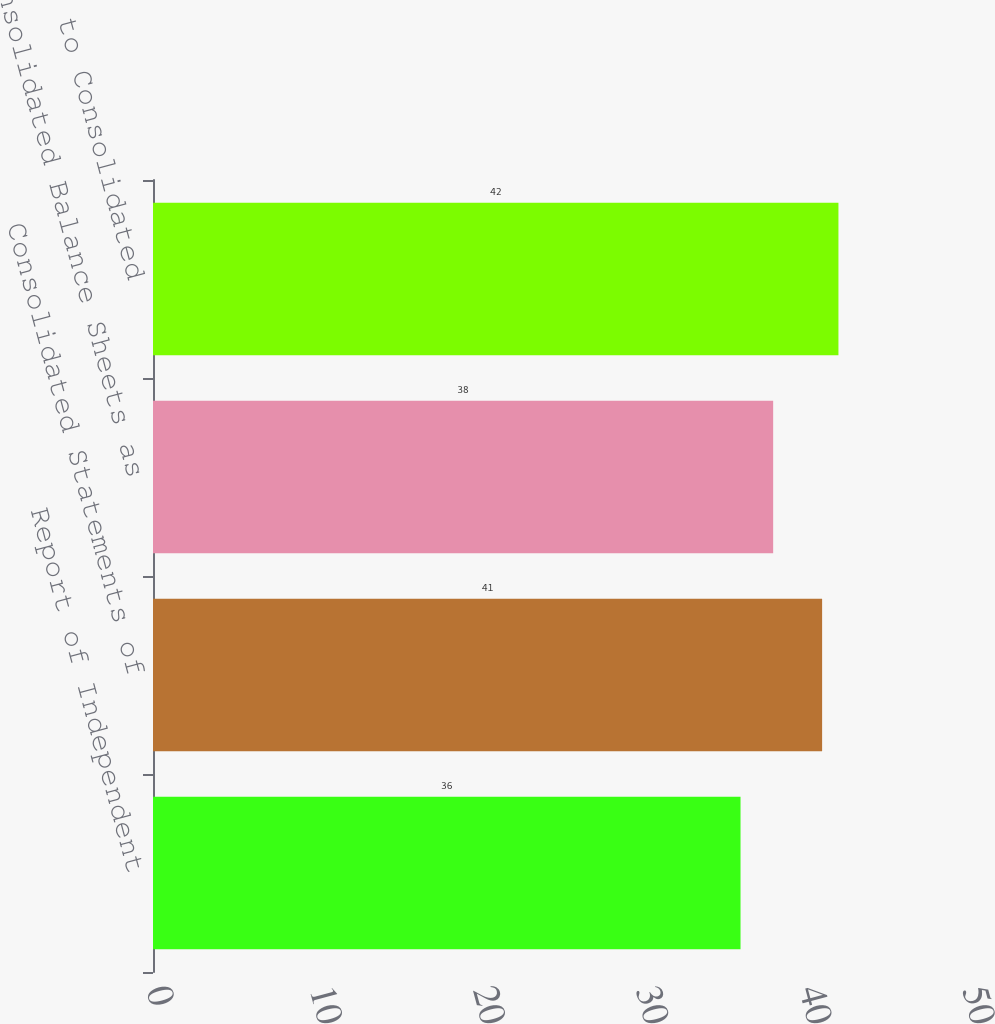Convert chart. <chart><loc_0><loc_0><loc_500><loc_500><bar_chart><fcel>Report of Independent<fcel>Consolidated Statements of<fcel>Consolidated Balance Sheets as<fcel>Notes to Consolidated<nl><fcel>36<fcel>41<fcel>38<fcel>42<nl></chart> 